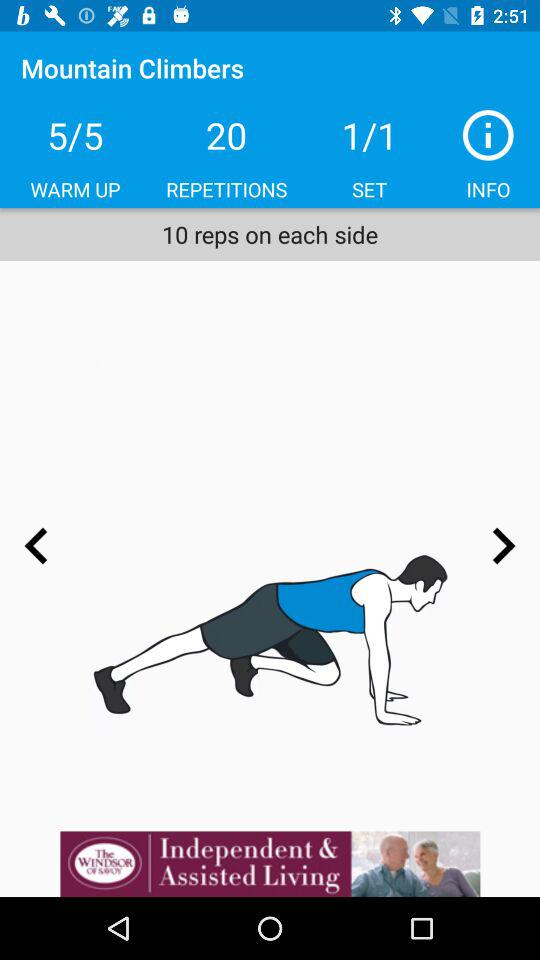What set am I on? The set is 1. 